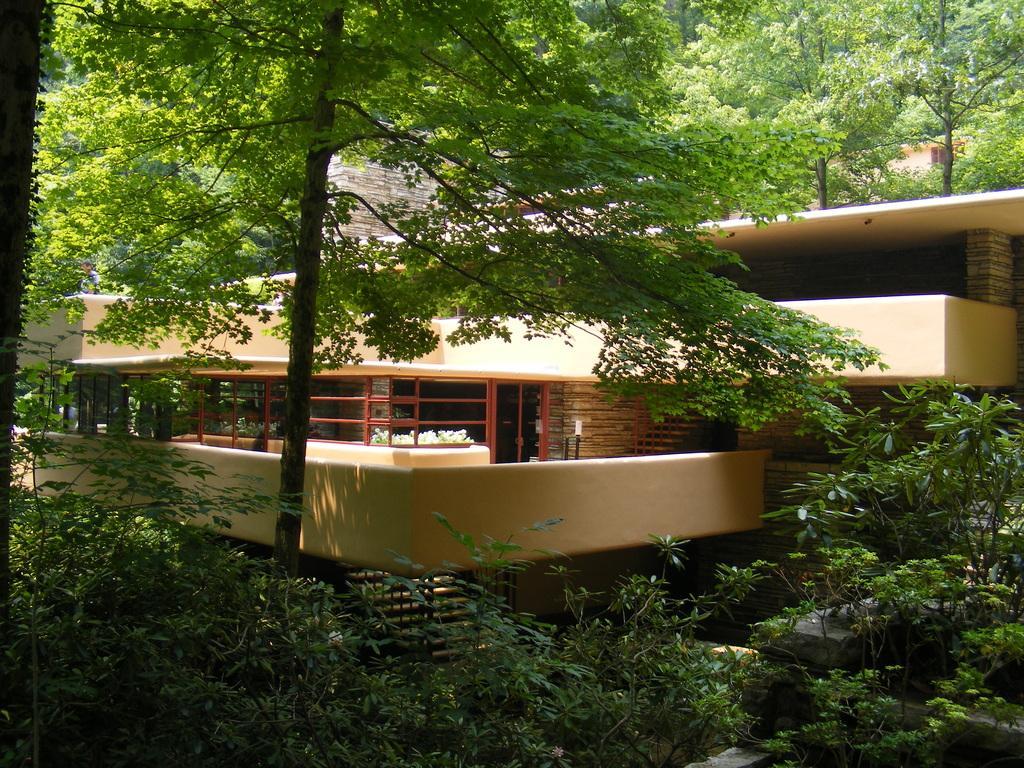How would you summarize this image in a sentence or two? In this image I can see trees and a building. 